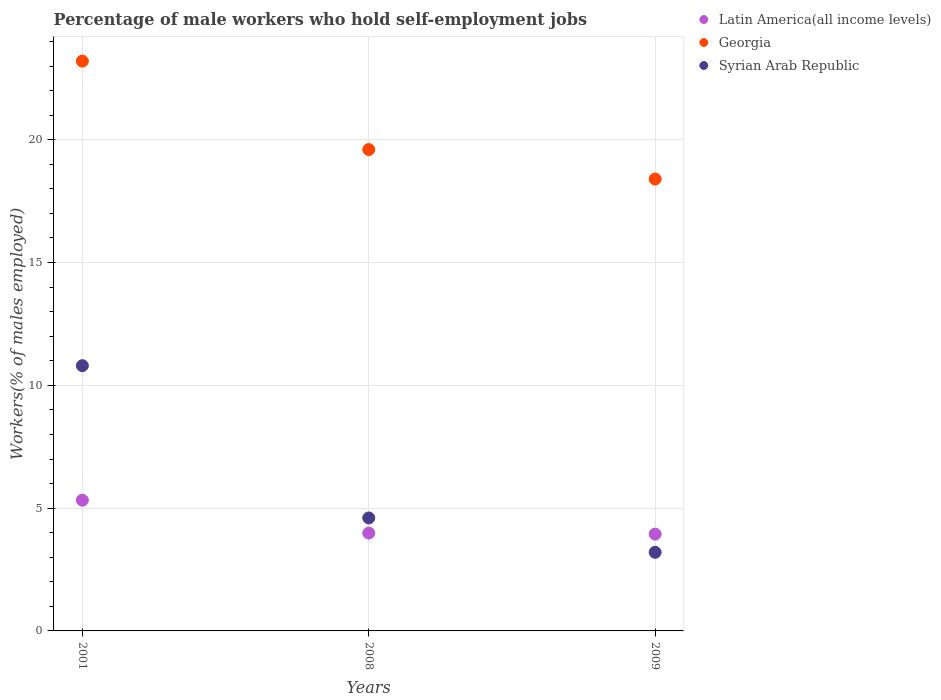How many different coloured dotlines are there?
Give a very brief answer. 3. Is the number of dotlines equal to the number of legend labels?
Ensure brevity in your answer.  Yes. What is the percentage of self-employed male workers in Syrian Arab Republic in 2008?
Your response must be concise. 4.6. Across all years, what is the maximum percentage of self-employed male workers in Georgia?
Keep it short and to the point. 23.2. Across all years, what is the minimum percentage of self-employed male workers in Georgia?
Your response must be concise. 18.4. In which year was the percentage of self-employed male workers in Latin America(all income levels) minimum?
Your response must be concise. 2009. What is the total percentage of self-employed male workers in Syrian Arab Republic in the graph?
Offer a very short reply. 18.6. What is the difference between the percentage of self-employed male workers in Georgia in 2001 and that in 2008?
Your answer should be very brief. 3.6. What is the difference between the percentage of self-employed male workers in Latin America(all income levels) in 2008 and the percentage of self-employed male workers in Syrian Arab Republic in 2009?
Make the answer very short. 0.78. What is the average percentage of self-employed male workers in Syrian Arab Republic per year?
Offer a terse response. 6.2. In the year 2001, what is the difference between the percentage of self-employed male workers in Latin America(all income levels) and percentage of self-employed male workers in Syrian Arab Republic?
Your answer should be very brief. -5.48. What is the ratio of the percentage of self-employed male workers in Latin America(all income levels) in 2001 to that in 2009?
Your answer should be very brief. 1.35. Is the difference between the percentage of self-employed male workers in Latin America(all income levels) in 2001 and 2009 greater than the difference between the percentage of self-employed male workers in Syrian Arab Republic in 2001 and 2009?
Make the answer very short. No. What is the difference between the highest and the second highest percentage of self-employed male workers in Latin America(all income levels)?
Your answer should be compact. 1.34. What is the difference between the highest and the lowest percentage of self-employed male workers in Georgia?
Make the answer very short. 4.8. Is the percentage of self-employed male workers in Georgia strictly greater than the percentage of self-employed male workers in Latin America(all income levels) over the years?
Offer a very short reply. Yes. What is the difference between two consecutive major ticks on the Y-axis?
Your response must be concise. 5. Does the graph contain grids?
Keep it short and to the point. Yes. Where does the legend appear in the graph?
Your response must be concise. Top right. What is the title of the graph?
Your response must be concise. Percentage of male workers who hold self-employment jobs. What is the label or title of the Y-axis?
Offer a terse response. Workers(% of males employed). What is the Workers(% of males employed) of Latin America(all income levels) in 2001?
Your response must be concise. 5.32. What is the Workers(% of males employed) of Georgia in 2001?
Offer a terse response. 23.2. What is the Workers(% of males employed) of Syrian Arab Republic in 2001?
Keep it short and to the point. 10.8. What is the Workers(% of males employed) in Latin America(all income levels) in 2008?
Your response must be concise. 3.98. What is the Workers(% of males employed) in Georgia in 2008?
Keep it short and to the point. 19.6. What is the Workers(% of males employed) of Syrian Arab Republic in 2008?
Your answer should be very brief. 4.6. What is the Workers(% of males employed) in Latin America(all income levels) in 2009?
Offer a very short reply. 3.94. What is the Workers(% of males employed) in Georgia in 2009?
Your answer should be very brief. 18.4. What is the Workers(% of males employed) of Syrian Arab Republic in 2009?
Your response must be concise. 3.2. Across all years, what is the maximum Workers(% of males employed) of Latin America(all income levels)?
Provide a short and direct response. 5.32. Across all years, what is the maximum Workers(% of males employed) of Georgia?
Offer a terse response. 23.2. Across all years, what is the maximum Workers(% of males employed) of Syrian Arab Republic?
Ensure brevity in your answer.  10.8. Across all years, what is the minimum Workers(% of males employed) in Latin America(all income levels)?
Make the answer very short. 3.94. Across all years, what is the minimum Workers(% of males employed) of Georgia?
Your response must be concise. 18.4. Across all years, what is the minimum Workers(% of males employed) in Syrian Arab Republic?
Your answer should be compact. 3.2. What is the total Workers(% of males employed) in Latin America(all income levels) in the graph?
Your answer should be compact. 13.25. What is the total Workers(% of males employed) of Georgia in the graph?
Provide a succinct answer. 61.2. What is the difference between the Workers(% of males employed) of Latin America(all income levels) in 2001 and that in 2008?
Your answer should be compact. 1.34. What is the difference between the Workers(% of males employed) in Syrian Arab Republic in 2001 and that in 2008?
Give a very brief answer. 6.2. What is the difference between the Workers(% of males employed) of Latin America(all income levels) in 2001 and that in 2009?
Offer a very short reply. 1.38. What is the difference between the Workers(% of males employed) in Georgia in 2001 and that in 2009?
Provide a short and direct response. 4.8. What is the difference between the Workers(% of males employed) in Syrian Arab Republic in 2001 and that in 2009?
Ensure brevity in your answer.  7.6. What is the difference between the Workers(% of males employed) in Latin America(all income levels) in 2008 and that in 2009?
Provide a short and direct response. 0.04. What is the difference between the Workers(% of males employed) in Latin America(all income levels) in 2001 and the Workers(% of males employed) in Georgia in 2008?
Your answer should be very brief. -14.28. What is the difference between the Workers(% of males employed) of Latin America(all income levels) in 2001 and the Workers(% of males employed) of Syrian Arab Republic in 2008?
Make the answer very short. 0.72. What is the difference between the Workers(% of males employed) of Georgia in 2001 and the Workers(% of males employed) of Syrian Arab Republic in 2008?
Your answer should be very brief. 18.6. What is the difference between the Workers(% of males employed) of Latin America(all income levels) in 2001 and the Workers(% of males employed) of Georgia in 2009?
Ensure brevity in your answer.  -13.08. What is the difference between the Workers(% of males employed) of Latin America(all income levels) in 2001 and the Workers(% of males employed) of Syrian Arab Republic in 2009?
Make the answer very short. 2.12. What is the difference between the Workers(% of males employed) of Latin America(all income levels) in 2008 and the Workers(% of males employed) of Georgia in 2009?
Offer a terse response. -14.42. What is the difference between the Workers(% of males employed) of Latin America(all income levels) in 2008 and the Workers(% of males employed) of Syrian Arab Republic in 2009?
Make the answer very short. 0.78. What is the difference between the Workers(% of males employed) of Georgia in 2008 and the Workers(% of males employed) of Syrian Arab Republic in 2009?
Your response must be concise. 16.4. What is the average Workers(% of males employed) in Latin America(all income levels) per year?
Your answer should be compact. 4.42. What is the average Workers(% of males employed) of Georgia per year?
Offer a terse response. 20.4. What is the average Workers(% of males employed) of Syrian Arab Republic per year?
Offer a terse response. 6.2. In the year 2001, what is the difference between the Workers(% of males employed) of Latin America(all income levels) and Workers(% of males employed) of Georgia?
Give a very brief answer. -17.88. In the year 2001, what is the difference between the Workers(% of males employed) in Latin America(all income levels) and Workers(% of males employed) in Syrian Arab Republic?
Give a very brief answer. -5.48. In the year 2001, what is the difference between the Workers(% of males employed) in Georgia and Workers(% of males employed) in Syrian Arab Republic?
Offer a terse response. 12.4. In the year 2008, what is the difference between the Workers(% of males employed) of Latin America(all income levels) and Workers(% of males employed) of Georgia?
Give a very brief answer. -15.62. In the year 2008, what is the difference between the Workers(% of males employed) of Latin America(all income levels) and Workers(% of males employed) of Syrian Arab Republic?
Make the answer very short. -0.62. In the year 2009, what is the difference between the Workers(% of males employed) in Latin America(all income levels) and Workers(% of males employed) in Georgia?
Offer a very short reply. -14.46. In the year 2009, what is the difference between the Workers(% of males employed) in Latin America(all income levels) and Workers(% of males employed) in Syrian Arab Republic?
Your response must be concise. 0.74. In the year 2009, what is the difference between the Workers(% of males employed) of Georgia and Workers(% of males employed) of Syrian Arab Republic?
Give a very brief answer. 15.2. What is the ratio of the Workers(% of males employed) in Latin America(all income levels) in 2001 to that in 2008?
Your answer should be very brief. 1.34. What is the ratio of the Workers(% of males employed) of Georgia in 2001 to that in 2008?
Provide a short and direct response. 1.18. What is the ratio of the Workers(% of males employed) in Syrian Arab Republic in 2001 to that in 2008?
Your response must be concise. 2.35. What is the ratio of the Workers(% of males employed) of Latin America(all income levels) in 2001 to that in 2009?
Keep it short and to the point. 1.35. What is the ratio of the Workers(% of males employed) in Georgia in 2001 to that in 2009?
Make the answer very short. 1.26. What is the ratio of the Workers(% of males employed) of Syrian Arab Republic in 2001 to that in 2009?
Provide a short and direct response. 3.38. What is the ratio of the Workers(% of males employed) of Latin America(all income levels) in 2008 to that in 2009?
Your response must be concise. 1.01. What is the ratio of the Workers(% of males employed) in Georgia in 2008 to that in 2009?
Your answer should be compact. 1.07. What is the ratio of the Workers(% of males employed) in Syrian Arab Republic in 2008 to that in 2009?
Offer a terse response. 1.44. What is the difference between the highest and the second highest Workers(% of males employed) in Latin America(all income levels)?
Your response must be concise. 1.34. What is the difference between the highest and the second highest Workers(% of males employed) of Syrian Arab Republic?
Give a very brief answer. 6.2. What is the difference between the highest and the lowest Workers(% of males employed) of Latin America(all income levels)?
Ensure brevity in your answer.  1.38. What is the difference between the highest and the lowest Workers(% of males employed) of Georgia?
Offer a terse response. 4.8. 